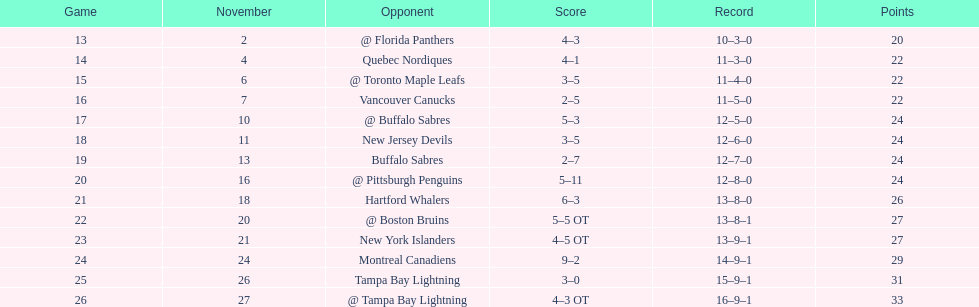Were the new jersey devils in last place according to the chart? No. 